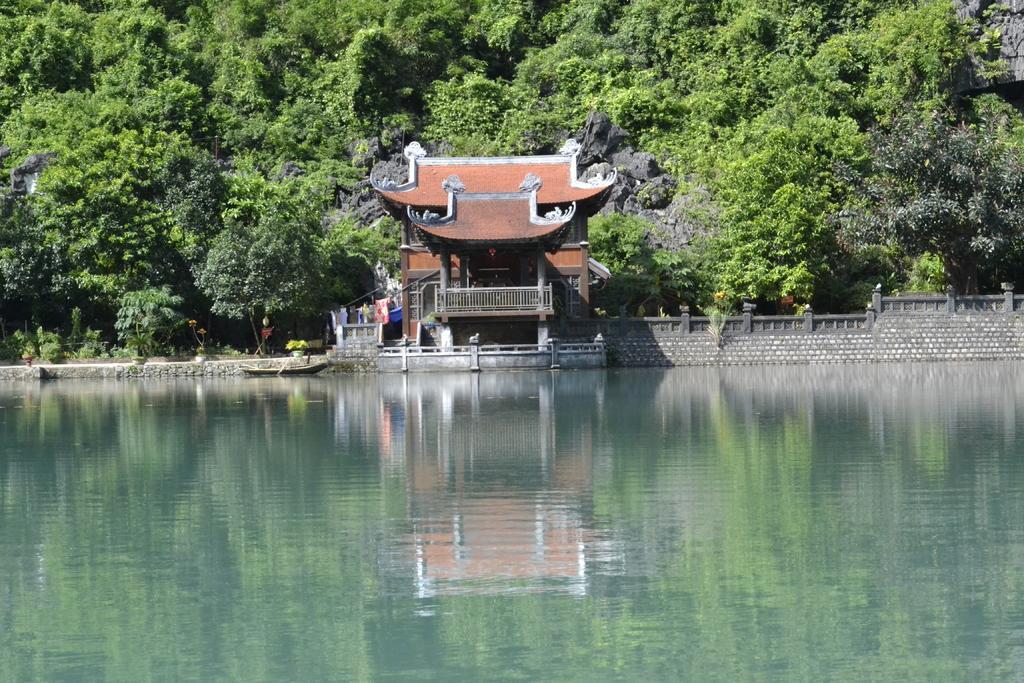Please provide a concise description of this image. In this image we can see water and a boat. We can also see a building and number of trees in the background. 